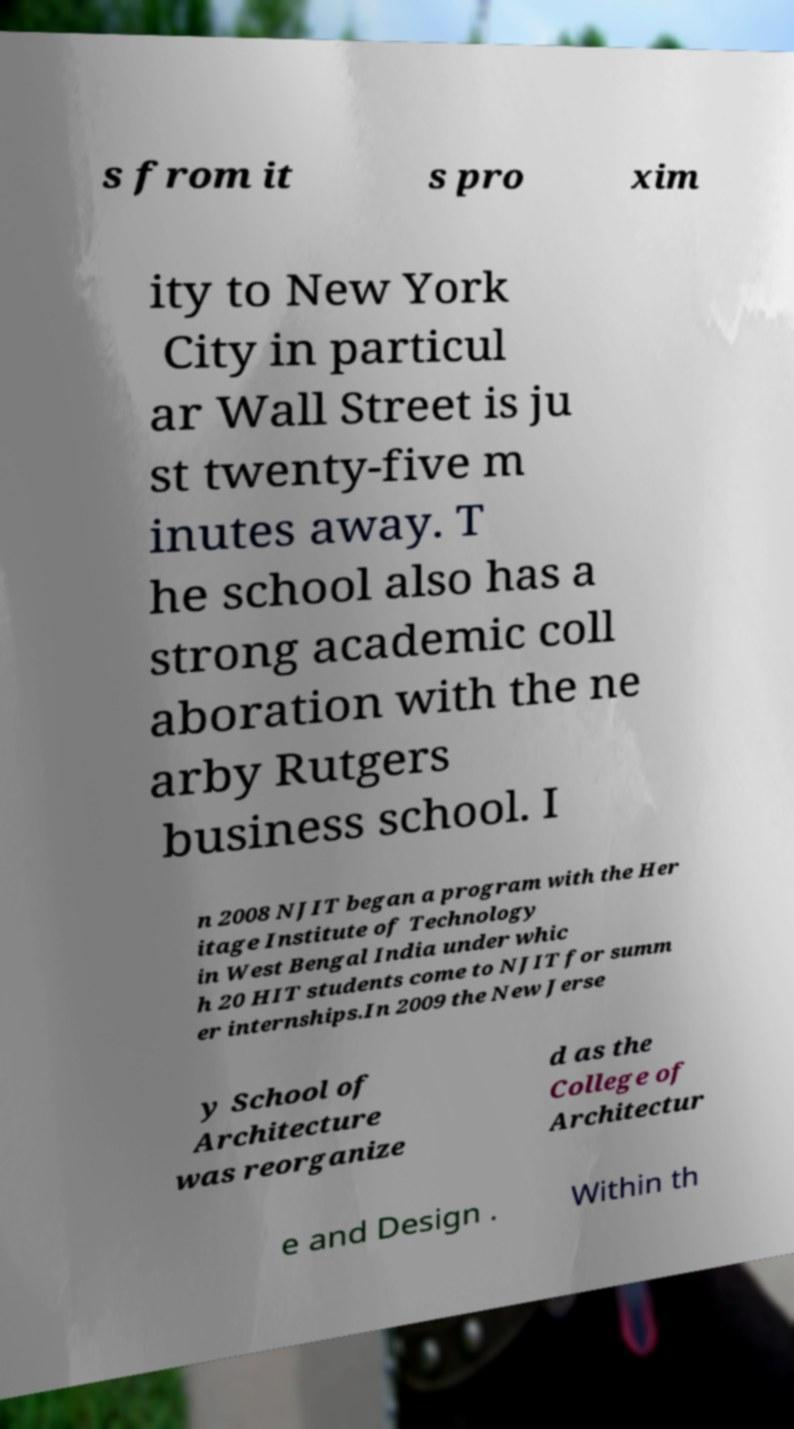What messages or text are displayed in this image? I need them in a readable, typed format. s from it s pro xim ity to New York City in particul ar Wall Street is ju st twenty-five m inutes away. T he school also has a strong academic coll aboration with the ne arby Rutgers business school. I n 2008 NJIT began a program with the Her itage Institute of Technology in West Bengal India under whic h 20 HIT students come to NJIT for summ er internships.In 2009 the New Jerse y School of Architecture was reorganize d as the College of Architectur e and Design . Within th 